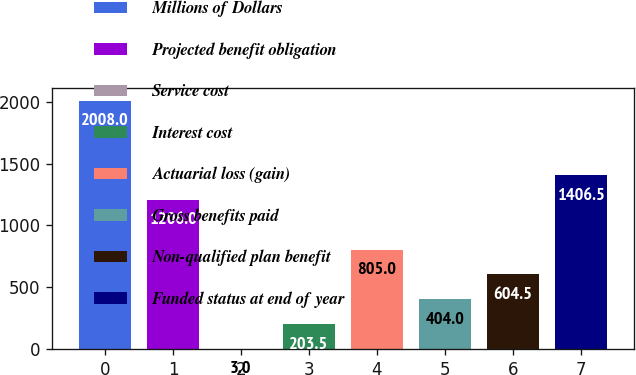<chart> <loc_0><loc_0><loc_500><loc_500><bar_chart><fcel>Millions of Dollars<fcel>Projected benefit obligation<fcel>Service cost<fcel>Interest cost<fcel>Actuarial loss (gain)<fcel>Gross benefits paid<fcel>Non-qualified plan benefit<fcel>Funded status at end of year<nl><fcel>2008<fcel>1206<fcel>3<fcel>203.5<fcel>805<fcel>404<fcel>604.5<fcel>1406.5<nl></chart> 